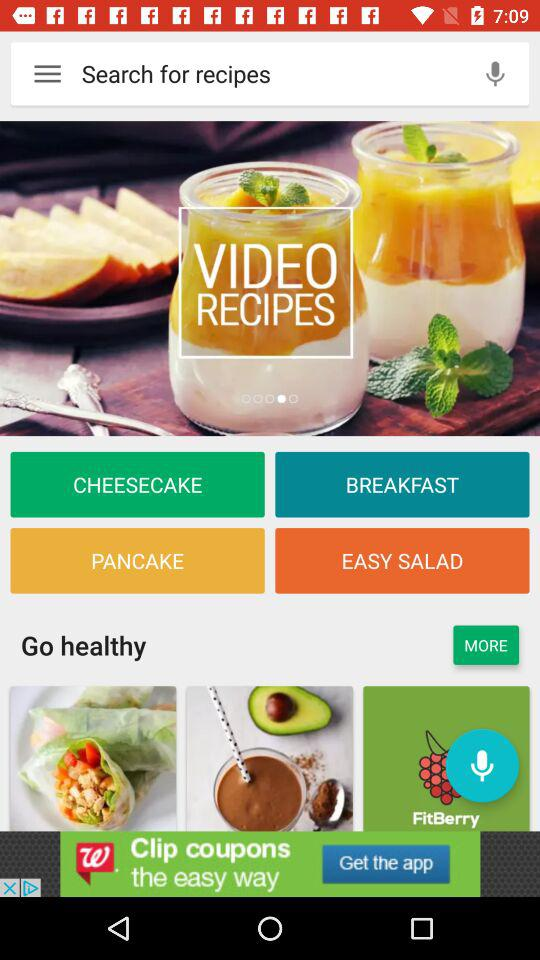Which are the different recipes?
When the provided information is insufficient, respond with <no answer>. <no answer> 